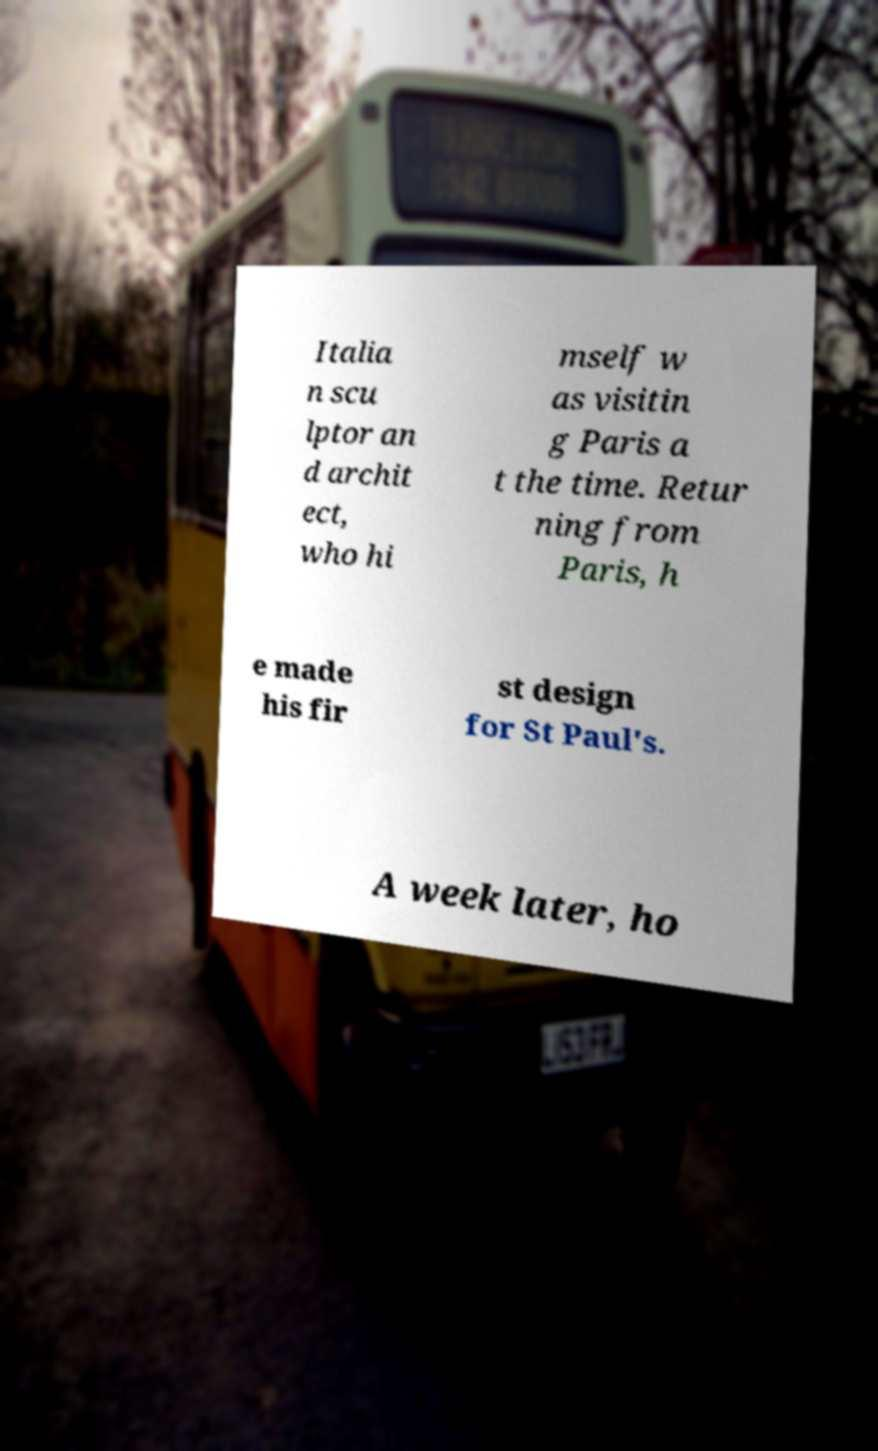I need the written content from this picture converted into text. Can you do that? Italia n scu lptor an d archit ect, who hi mself w as visitin g Paris a t the time. Retur ning from Paris, h e made his fir st design for St Paul's. A week later, ho 